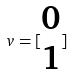Convert formula to latex. <formula><loc_0><loc_0><loc_500><loc_500>v = [ \begin{matrix} 0 \\ 1 \end{matrix} ]</formula> 